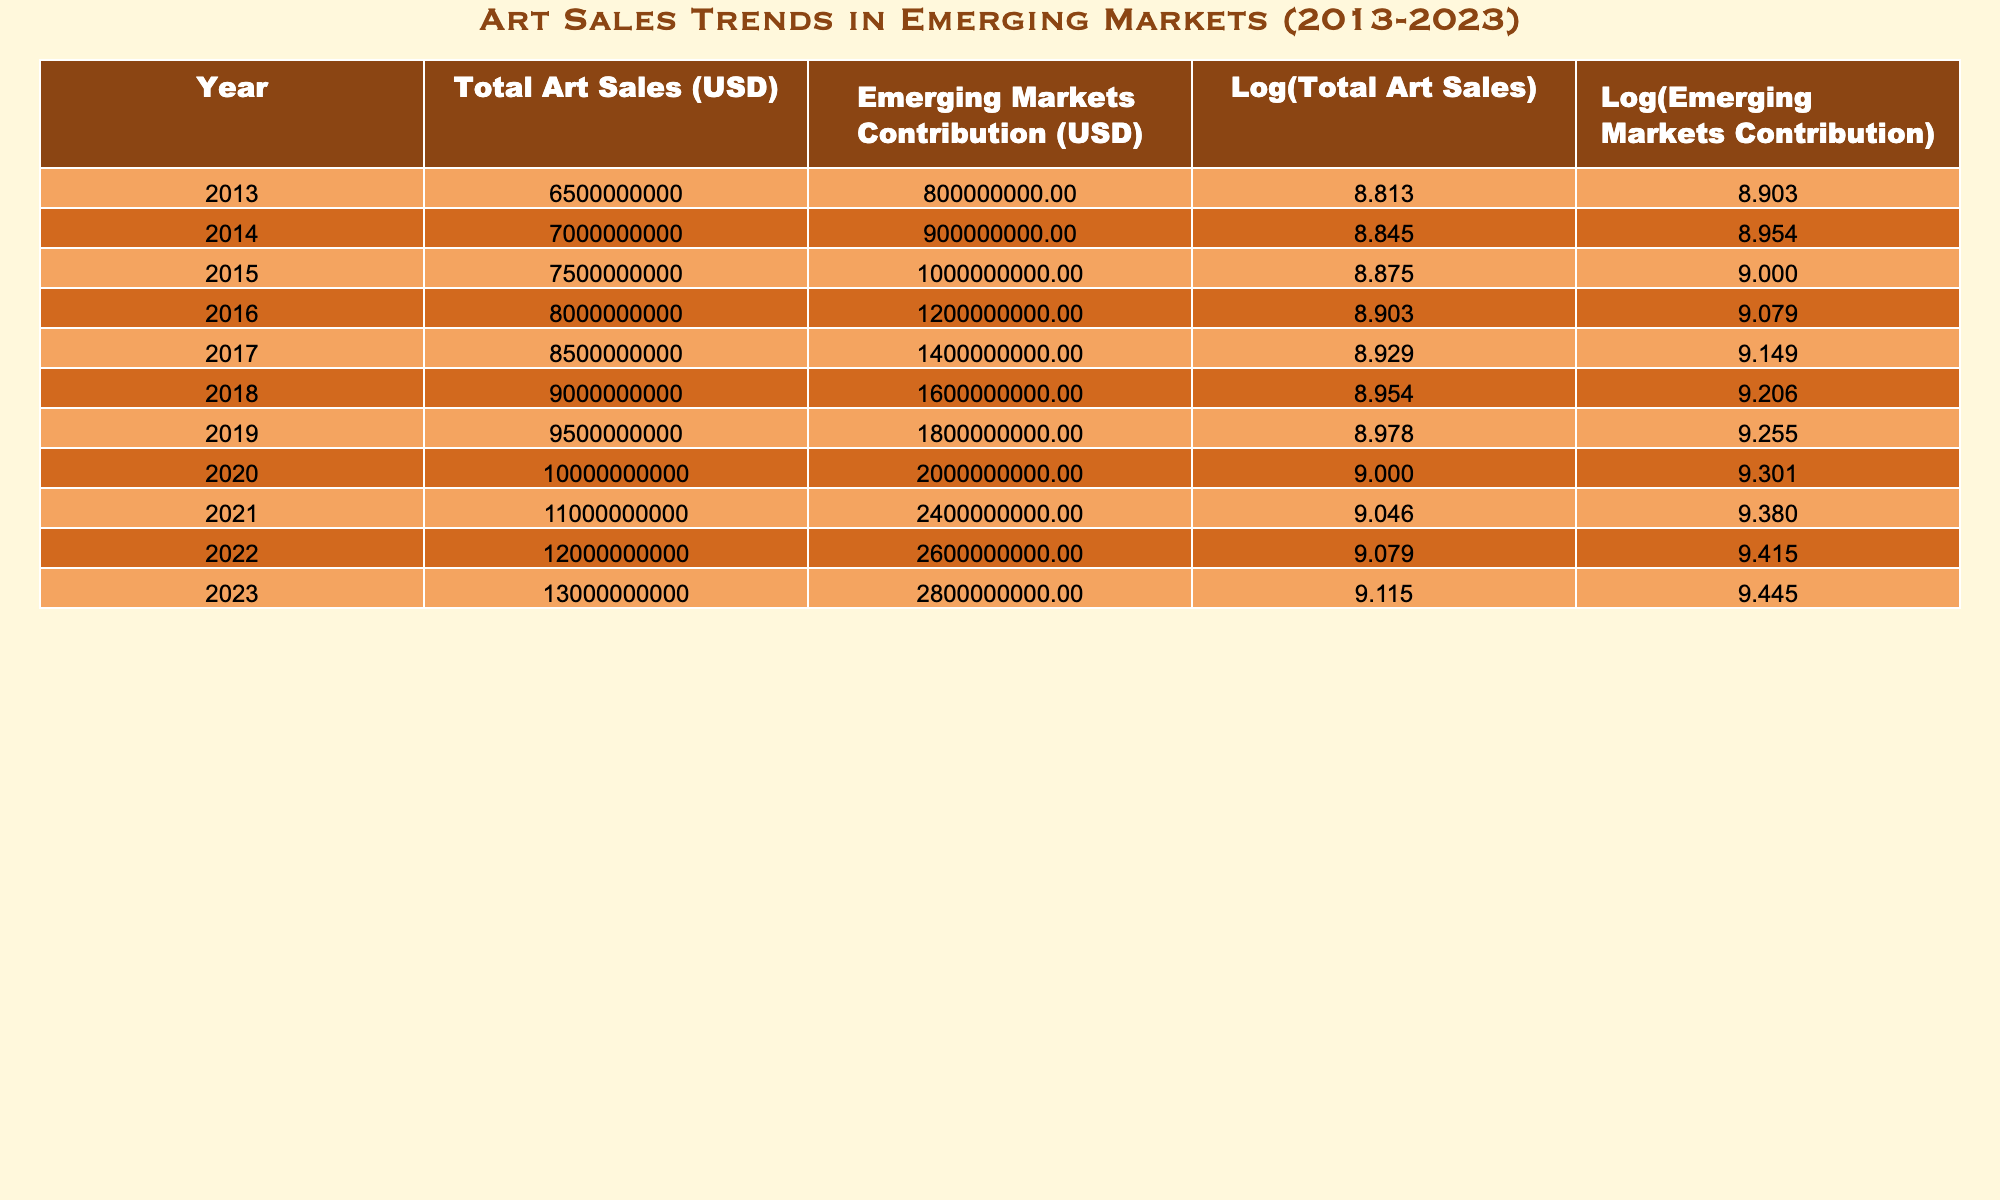What was the total art sales amount in 2019? Referring to the table, the total art sales for the year 2019 is recorded as 9500000000 USD.
Answer: 9500000000 USD What was the contribution of emerging markets to total art sales in 2020? In the table, for the year 2020, the contribution of emerging markets is 2000000000 USD, as listed under that year.
Answer: 2000000000 USD What is the average total art sales from 2013 to 2023? Total art sales from 2013 to 2023 are: 6500000000, 7000000000, 7500000000, 8000000000, 8500000000, 9000000000, 9500000000, 10000000000, 11000000000, 12000000000, 13000000000. By summing these values (6500000000 + 7000000000 + 7500000000 + 8000000000 + 8500000000 + 9000000000 + 9500000000 + 10000000000 + 11000000000 + 12000000000 + 13000000000 =  83500000000) and dividing by 11 (the number of years) gives the average: 83500000000 / 11 = 7600000000.
Answer: 7600000000 Was there an increase in the contribution of emerging markets from 2015 to 2016? Looking at the data for 2015 and 2016, the emerging markets contribution was 1000000000 USD in 2015 and increased to 1200000000 USD in 2016. This shows a growth, thus the answer is yes.
Answer: Yes What is the difference in emerging markets contribution between 2022 and 2023? The values for emerging markets contribution in 2022 and 2023 are 2600000000 USD and 2800000000 USD, respectively. To find the difference, subtract 2022's value from 2023's value: 2800000000 - 2600000000 = 200000000.
Answer: 200000000 What percentage of total art sales did emerging markets contribute in 2018? In 2018, the emerging markets contribution was 1600000000 USD and total art sales were 9000000000 USD. To find the percentage, divide the emerging markets contribution by the total art sales and multiply by 100: (1600000000 / 9000000000) * 100 = 17.78%.
Answer: 17.78% Did the total art sales grow consistently every year from 2013 to 2023? By reviewing the table, it is clear that total art sales increased each year without any decreases in between 2013 and 2023, confirming a consistent growth pattern.
Answer: Yes What was the logarithmic value of total art sales in 2016? According to the table, the logarithmic value of total art sales for the year 2016 is 8.903.
Answer: 8.903 What was the maximum contribution of emerging markets in any given year within the period? The maximum emerging markets contribution can be identified within the years provided. Reviewing the data shows that the highest value was 2800000000 USD, observed in 2023.
Answer: 2800000000 USD 